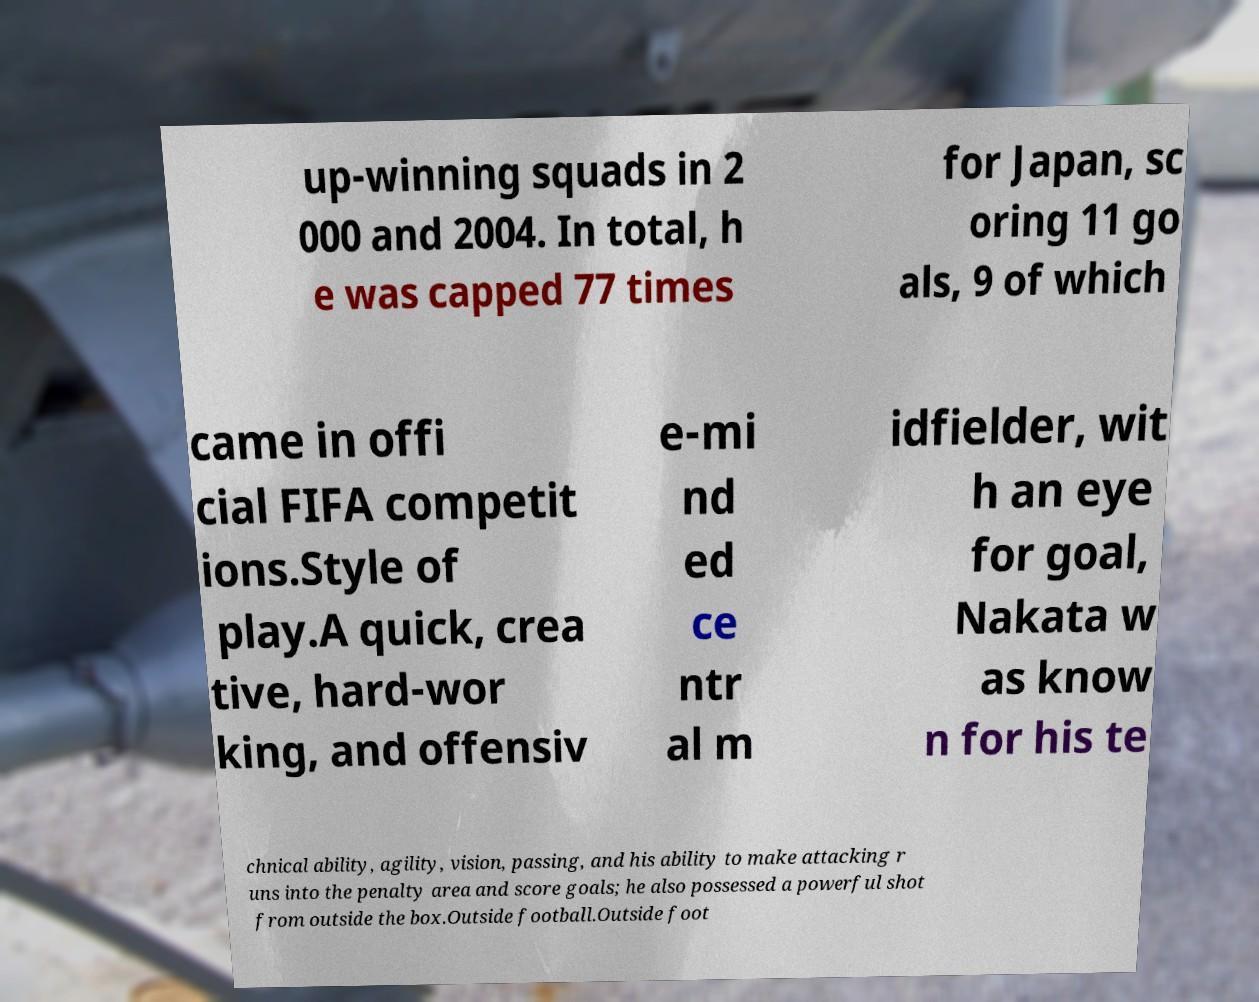What messages or text are displayed in this image? I need them in a readable, typed format. up-winning squads in 2 000 and 2004. In total, h e was capped 77 times for Japan, sc oring 11 go als, 9 of which came in offi cial FIFA competit ions.Style of play.A quick, crea tive, hard-wor king, and offensiv e-mi nd ed ce ntr al m idfielder, wit h an eye for goal, Nakata w as know n for his te chnical ability, agility, vision, passing, and his ability to make attacking r uns into the penalty area and score goals; he also possessed a powerful shot from outside the box.Outside football.Outside foot 